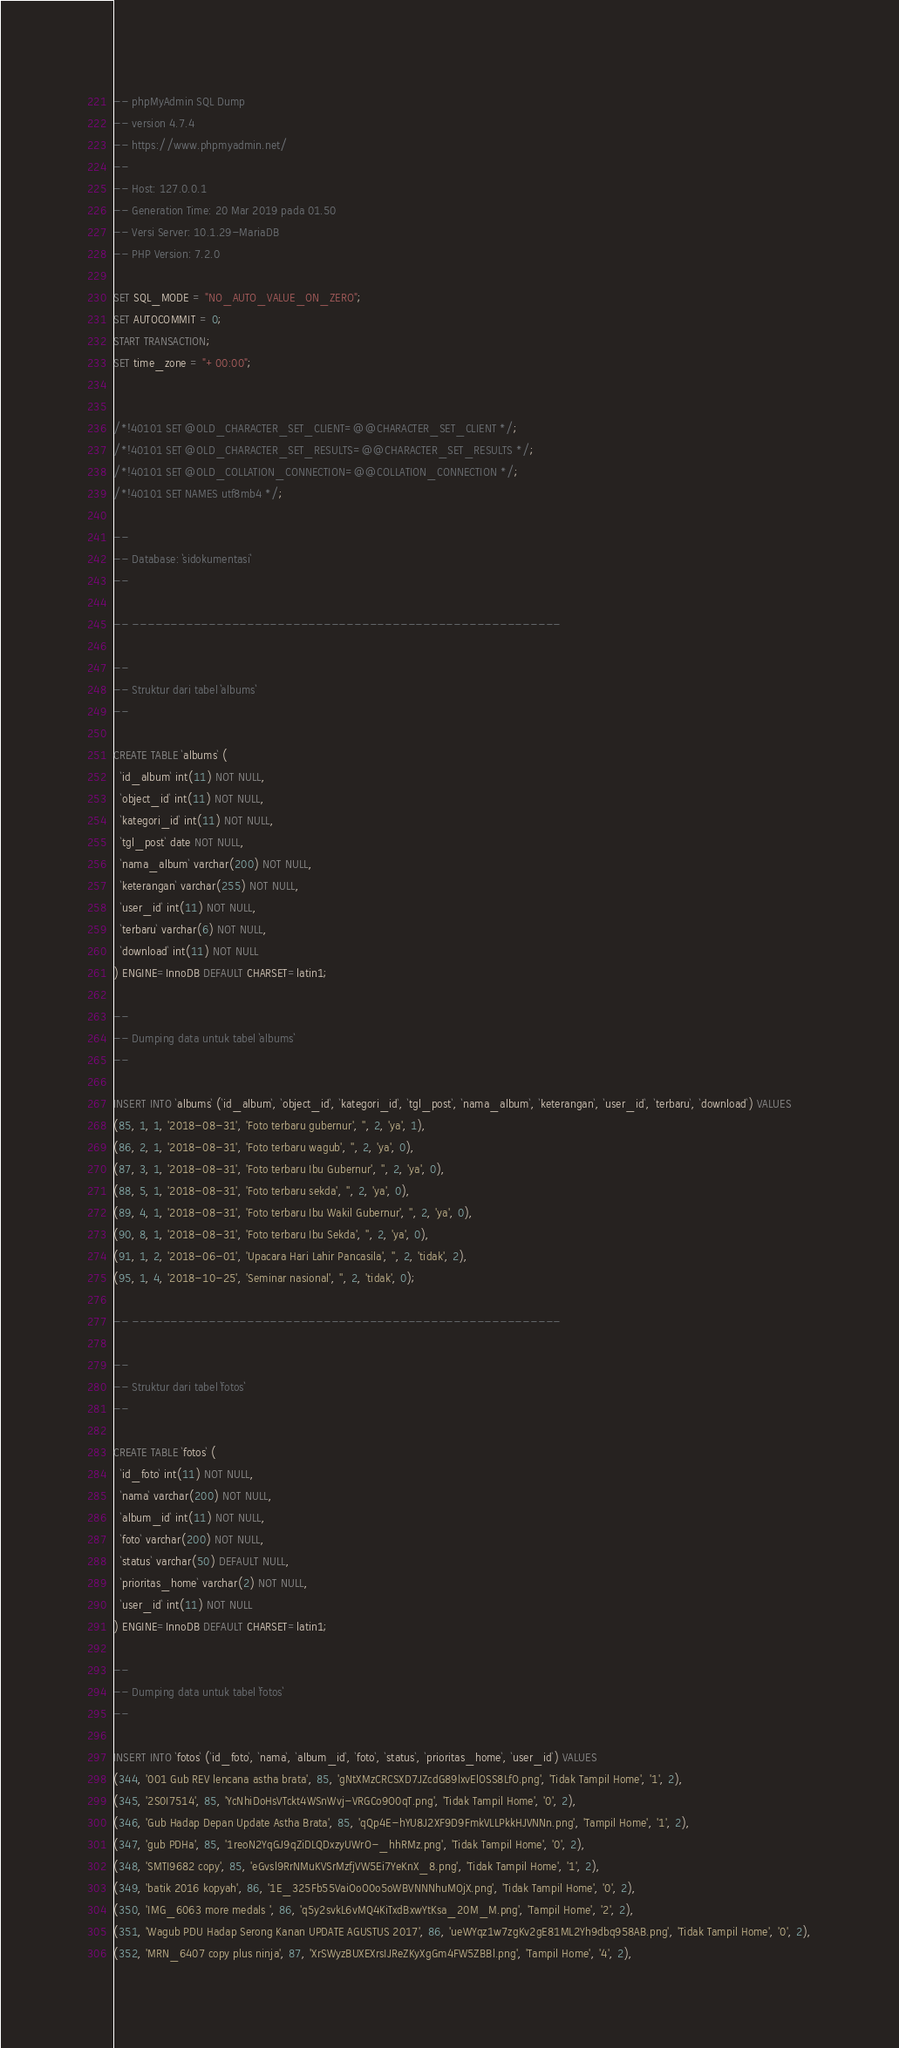<code> <loc_0><loc_0><loc_500><loc_500><_SQL_>-- phpMyAdmin SQL Dump
-- version 4.7.4
-- https://www.phpmyadmin.net/
--
-- Host: 127.0.0.1
-- Generation Time: 20 Mar 2019 pada 01.50
-- Versi Server: 10.1.29-MariaDB
-- PHP Version: 7.2.0

SET SQL_MODE = "NO_AUTO_VALUE_ON_ZERO";
SET AUTOCOMMIT = 0;
START TRANSACTION;
SET time_zone = "+00:00";


/*!40101 SET @OLD_CHARACTER_SET_CLIENT=@@CHARACTER_SET_CLIENT */;
/*!40101 SET @OLD_CHARACTER_SET_RESULTS=@@CHARACTER_SET_RESULTS */;
/*!40101 SET @OLD_COLLATION_CONNECTION=@@COLLATION_CONNECTION */;
/*!40101 SET NAMES utf8mb4 */;

--
-- Database: `sidokumentasi`
--

-- --------------------------------------------------------

--
-- Struktur dari tabel `albums`
--

CREATE TABLE `albums` (
  `id_album` int(11) NOT NULL,
  `object_id` int(11) NOT NULL,
  `kategori_id` int(11) NOT NULL,
  `tgl_post` date NOT NULL,
  `nama_album` varchar(200) NOT NULL,
  `keterangan` varchar(255) NOT NULL,
  `user_id` int(11) NOT NULL,
  `terbaru` varchar(6) NOT NULL,
  `download` int(11) NOT NULL
) ENGINE=InnoDB DEFAULT CHARSET=latin1;

--
-- Dumping data untuk tabel `albums`
--

INSERT INTO `albums` (`id_album`, `object_id`, `kategori_id`, `tgl_post`, `nama_album`, `keterangan`, `user_id`, `terbaru`, `download`) VALUES
(85, 1, 1, '2018-08-31', 'Foto terbaru gubernur', '', 2, 'ya', 1),
(86, 2, 1, '2018-08-31', 'Foto terbaru wagub', '', 2, 'ya', 0),
(87, 3, 1, '2018-08-31', 'Foto terbaru Ibu Gubernur', '', 2, 'ya', 0),
(88, 5, 1, '2018-08-31', 'Foto terbaru sekda', '', 2, 'ya', 0),
(89, 4, 1, '2018-08-31', 'Foto terbaru Ibu Wakil Gubernur', '', 2, 'ya', 0),
(90, 8, 1, '2018-08-31', 'Foto terbaru Ibu Sekda', '', 2, 'ya', 0),
(91, 1, 2, '2018-06-01', 'Upacara Hari Lahir Pancasila', '', 2, 'tidak', 2),
(95, 1, 4, '2018-10-25', 'Seminar nasional', '', 2, 'tidak', 0);

-- --------------------------------------------------------

--
-- Struktur dari tabel `fotos`
--

CREATE TABLE `fotos` (
  `id_foto` int(11) NOT NULL,
  `nama` varchar(200) NOT NULL,
  `album_id` int(11) NOT NULL,
  `foto` varchar(200) NOT NULL,
  `status` varchar(50) DEFAULT NULL,
  `prioritas_home` varchar(2) NOT NULL,
  `user_id` int(11) NOT NULL
) ENGINE=InnoDB DEFAULT CHARSET=latin1;

--
-- Dumping data untuk tabel `fotos`
--

INSERT INTO `fotos` (`id_foto`, `nama`, `album_id`, `foto`, `status`, `prioritas_home`, `user_id`) VALUES
(344, '001 Gub REV lencana astha brata', 85, 'gNtXMzCRCSXD7JZcdG89lxvElOSS8LfO.png', 'Tidak Tampil Home', '1', 2),
(345, '2S0I7514', 85, 'YcNhiDoHsVTckt4WSnWvj-VRGCo9O0qT.png', 'Tidak Tampil Home', '0', 2),
(346, 'Gub Hadap Depan Update Astha Brata', 85, 'qQp4E-hYU8J2XF9D9FmkVLLPkkHJVNNn.png', 'Tampil Home', '1', 2),
(347, 'gub PDHa', 85, '1reoN2YqGJ9qZiDLQDxzyUWrO-_hhRMz.png', 'Tidak Tampil Home', '0', 2),
(348, 'SMTI9682 copy', 85, 'eGvsl9RrNMuKVSrMzfjVW5Ei7YeKnX_8.png', 'Tidak Tampil Home', '1', 2),
(349, 'batik 2016 kopyah', 86, '1E_325Fb55VaiOoO0o5oWBVNNNhuMOjX.png', 'Tidak Tampil Home', '0', 2),
(350, 'IMG_6063 more medals ', 86, 'q5y2svkL6vMQ4KiTxdBxwYtKsa_20M_M.png', 'Tampil Home', '2', 2),
(351, 'Wagub PDU Hadap Serong Kanan UPDATE AGUSTUS 2017', 86, 'ueWYqz1w7zgKv2gE81ML2Yh9dbq958AB.png', 'Tidak Tampil Home', '0', 2),
(352, 'MRN_6407 copy plus ninja', 87, 'XrSWyzBUXEXrsIJReZKyXgGm4FW5ZBBl.png', 'Tampil Home', '4', 2),</code> 